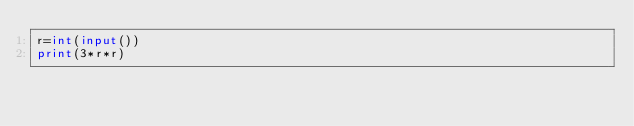Convert code to text. <code><loc_0><loc_0><loc_500><loc_500><_Python_>r=int(input())
print(3*r*r)</code> 